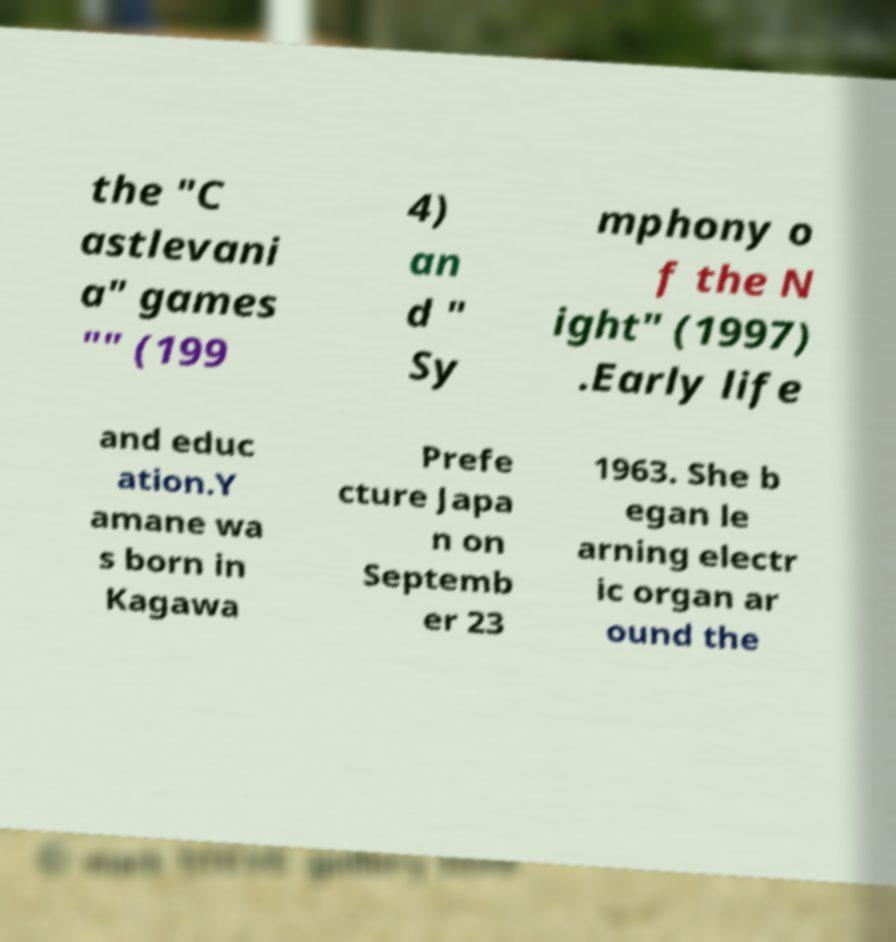What messages or text are displayed in this image? I need them in a readable, typed format. the "C astlevani a" games "" (199 4) an d " Sy mphony o f the N ight" (1997) .Early life and educ ation.Y amane wa s born in Kagawa Prefe cture Japa n on Septemb er 23 1963. She b egan le arning electr ic organ ar ound the 